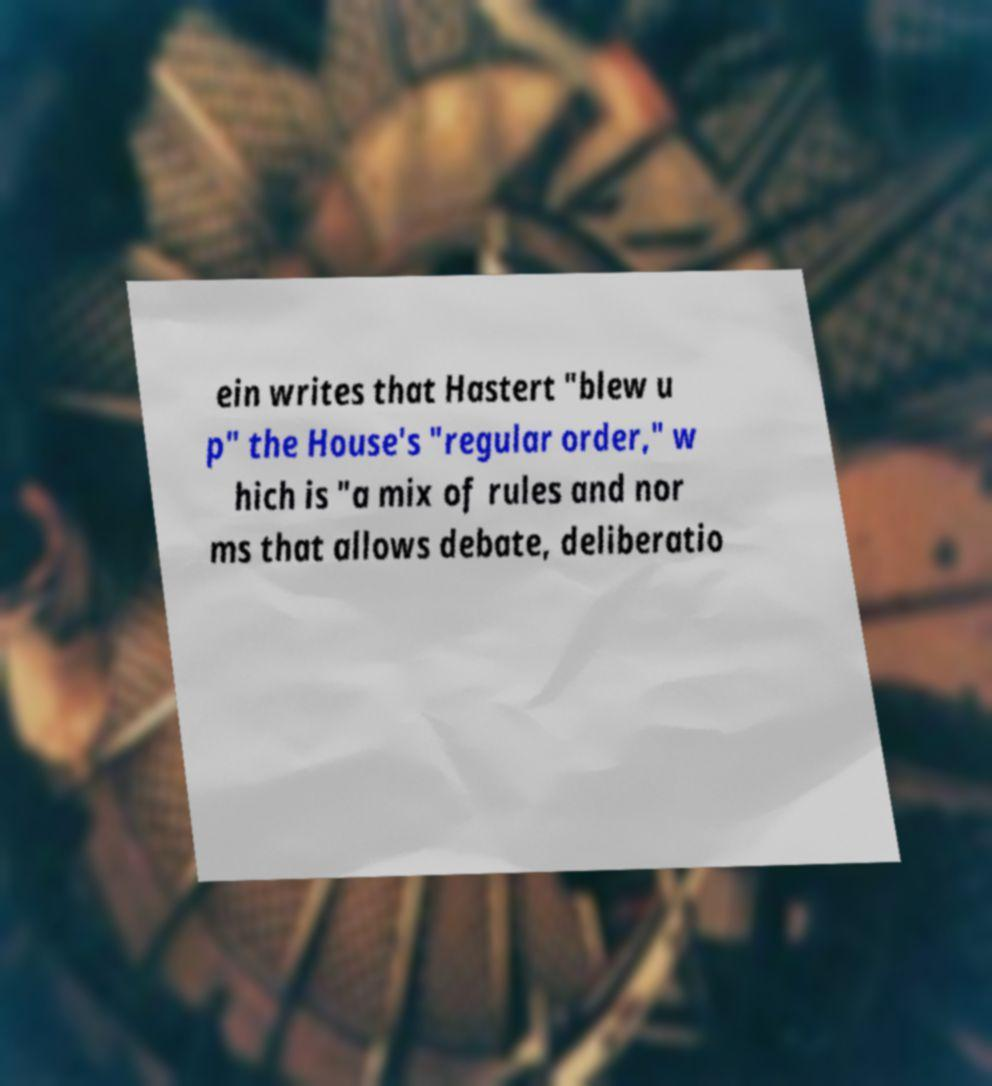Can you read and provide the text displayed in the image?This photo seems to have some interesting text. Can you extract and type it out for me? ein writes that Hastert "blew u p" the House's "regular order," w hich is "a mix of rules and nor ms that allows debate, deliberatio 